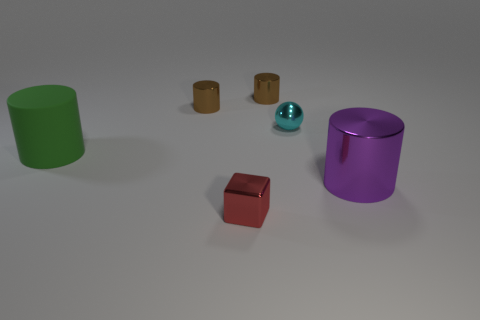Is the shape of the large green rubber thing the same as the small brown thing to the right of the block? While they both have a cylindrical shape, the large green object is a hollow cylinder, more specifically a tube, whereas the small brown object is a solid cylinder. So, while they share a similar geometry in terms of being cylinders, their forms differ in terms of solidity and possibly function. 